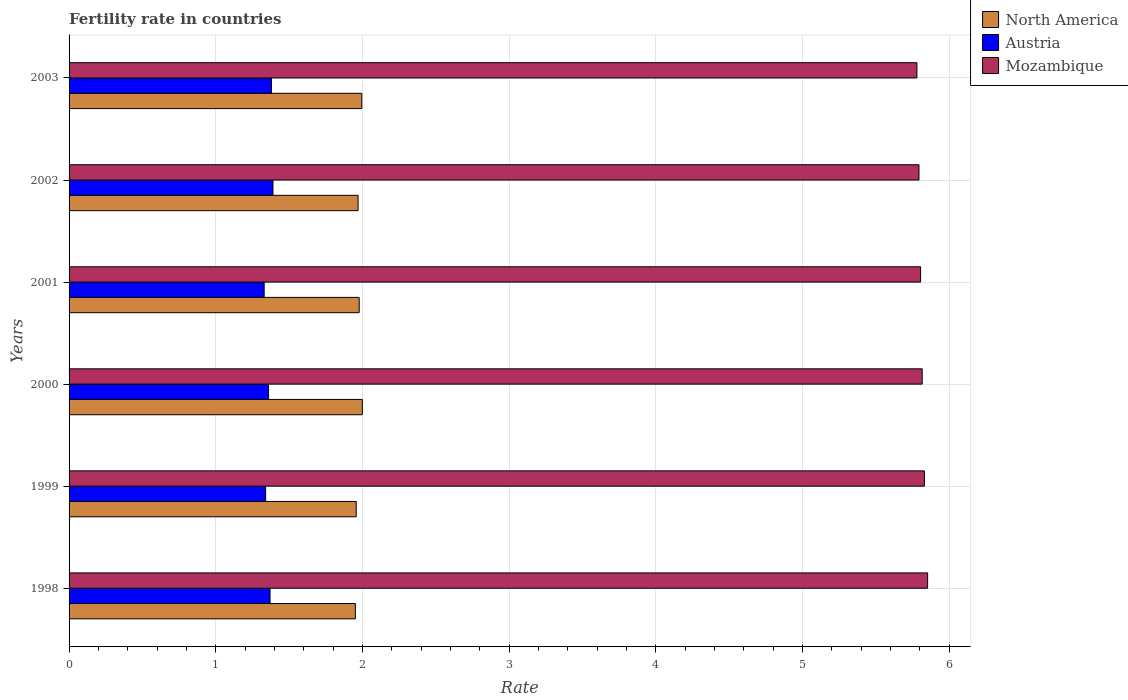How many groups of bars are there?
Offer a very short reply. 6. Are the number of bars per tick equal to the number of legend labels?
Provide a succinct answer. Yes. Are the number of bars on each tick of the Y-axis equal?
Provide a short and direct response. Yes. How many bars are there on the 6th tick from the bottom?
Provide a short and direct response. 3. What is the fertility rate in North America in 2000?
Provide a short and direct response. 2. Across all years, what is the maximum fertility rate in Mozambique?
Your answer should be very brief. 5.85. Across all years, what is the minimum fertility rate in Mozambique?
Give a very brief answer. 5.78. In which year was the fertility rate in North America minimum?
Offer a terse response. 1998. What is the total fertility rate in Mozambique in the graph?
Keep it short and to the point. 34.88. What is the difference between the fertility rate in North America in 1999 and that in 2002?
Keep it short and to the point. -0.01. What is the difference between the fertility rate in Austria in 2000 and the fertility rate in North America in 1998?
Your answer should be compact. -0.59. What is the average fertility rate in North America per year?
Offer a very short reply. 1.98. In the year 2002, what is the difference between the fertility rate in Austria and fertility rate in North America?
Ensure brevity in your answer.  -0.58. In how many years, is the fertility rate in Mozambique greater than 0.4 ?
Ensure brevity in your answer.  6. What is the ratio of the fertility rate in Mozambique in 2002 to that in 2003?
Make the answer very short. 1. Is the fertility rate in Mozambique in 1999 less than that in 2000?
Your answer should be compact. No. Is the difference between the fertility rate in Austria in 1998 and 2001 greater than the difference between the fertility rate in North America in 1998 and 2001?
Your response must be concise. Yes. What is the difference between the highest and the second highest fertility rate in Mozambique?
Keep it short and to the point. 0.02. What is the difference between the highest and the lowest fertility rate in Austria?
Your answer should be very brief. 0.06. How many years are there in the graph?
Provide a short and direct response. 6. Are the values on the major ticks of X-axis written in scientific E-notation?
Give a very brief answer. No. Does the graph contain grids?
Make the answer very short. Yes. Where does the legend appear in the graph?
Provide a succinct answer. Top right. How many legend labels are there?
Offer a very short reply. 3. What is the title of the graph?
Make the answer very short. Fertility rate in countries. What is the label or title of the X-axis?
Ensure brevity in your answer.  Rate. What is the Rate in North America in 1998?
Offer a terse response. 1.95. What is the Rate in Austria in 1998?
Give a very brief answer. 1.37. What is the Rate in Mozambique in 1998?
Your answer should be very brief. 5.85. What is the Rate in North America in 1999?
Offer a terse response. 1.96. What is the Rate in Austria in 1999?
Provide a succinct answer. 1.34. What is the Rate in Mozambique in 1999?
Make the answer very short. 5.83. What is the Rate in North America in 2000?
Provide a short and direct response. 2. What is the Rate in Austria in 2000?
Ensure brevity in your answer.  1.36. What is the Rate in Mozambique in 2000?
Your response must be concise. 5.82. What is the Rate of North America in 2001?
Offer a very short reply. 1.98. What is the Rate in Austria in 2001?
Provide a succinct answer. 1.33. What is the Rate in Mozambique in 2001?
Your response must be concise. 5.8. What is the Rate of North America in 2002?
Your answer should be compact. 1.97. What is the Rate in Austria in 2002?
Give a very brief answer. 1.39. What is the Rate of Mozambique in 2002?
Provide a succinct answer. 5.79. What is the Rate in North America in 2003?
Give a very brief answer. 2. What is the Rate of Austria in 2003?
Offer a terse response. 1.38. What is the Rate in Mozambique in 2003?
Make the answer very short. 5.78. Across all years, what is the maximum Rate in North America?
Your answer should be compact. 2. Across all years, what is the maximum Rate in Austria?
Provide a succinct answer. 1.39. Across all years, what is the maximum Rate in Mozambique?
Your answer should be compact. 5.85. Across all years, what is the minimum Rate of North America?
Your response must be concise. 1.95. Across all years, what is the minimum Rate in Austria?
Make the answer very short. 1.33. Across all years, what is the minimum Rate in Mozambique?
Give a very brief answer. 5.78. What is the total Rate in North America in the graph?
Ensure brevity in your answer.  11.85. What is the total Rate in Austria in the graph?
Your response must be concise. 8.17. What is the total Rate of Mozambique in the graph?
Keep it short and to the point. 34.88. What is the difference between the Rate of North America in 1998 and that in 1999?
Provide a short and direct response. -0.01. What is the difference between the Rate in Austria in 1998 and that in 1999?
Give a very brief answer. 0.03. What is the difference between the Rate in Mozambique in 1998 and that in 1999?
Ensure brevity in your answer.  0.02. What is the difference between the Rate of North America in 1998 and that in 2000?
Provide a short and direct response. -0.05. What is the difference between the Rate in Mozambique in 1998 and that in 2000?
Make the answer very short. 0.04. What is the difference between the Rate of North America in 1998 and that in 2001?
Your response must be concise. -0.03. What is the difference between the Rate of Mozambique in 1998 and that in 2001?
Give a very brief answer. 0.05. What is the difference between the Rate of North America in 1998 and that in 2002?
Offer a very short reply. -0.02. What is the difference between the Rate in Austria in 1998 and that in 2002?
Make the answer very short. -0.02. What is the difference between the Rate of Mozambique in 1998 and that in 2002?
Provide a succinct answer. 0.06. What is the difference between the Rate of North America in 1998 and that in 2003?
Offer a terse response. -0.04. What is the difference between the Rate in Austria in 1998 and that in 2003?
Offer a terse response. -0.01. What is the difference between the Rate of Mozambique in 1998 and that in 2003?
Ensure brevity in your answer.  0.07. What is the difference between the Rate of North America in 1999 and that in 2000?
Provide a succinct answer. -0.04. What is the difference between the Rate of Austria in 1999 and that in 2000?
Ensure brevity in your answer.  -0.02. What is the difference between the Rate in Mozambique in 1999 and that in 2000?
Provide a short and direct response. 0.01. What is the difference between the Rate in North America in 1999 and that in 2001?
Provide a short and direct response. -0.02. What is the difference between the Rate of Mozambique in 1999 and that in 2001?
Your answer should be compact. 0.03. What is the difference between the Rate in North America in 1999 and that in 2002?
Your answer should be compact. -0.01. What is the difference between the Rate of Mozambique in 1999 and that in 2002?
Your response must be concise. 0.04. What is the difference between the Rate of North America in 1999 and that in 2003?
Make the answer very short. -0.04. What is the difference between the Rate in Austria in 1999 and that in 2003?
Keep it short and to the point. -0.04. What is the difference between the Rate of Mozambique in 1999 and that in 2003?
Offer a terse response. 0.05. What is the difference between the Rate of North America in 2000 and that in 2001?
Give a very brief answer. 0.02. What is the difference between the Rate of Austria in 2000 and that in 2001?
Make the answer very short. 0.03. What is the difference between the Rate of Mozambique in 2000 and that in 2001?
Provide a succinct answer. 0.01. What is the difference between the Rate of North America in 2000 and that in 2002?
Your answer should be compact. 0.03. What is the difference between the Rate in Austria in 2000 and that in 2002?
Your answer should be very brief. -0.03. What is the difference between the Rate of Mozambique in 2000 and that in 2002?
Your response must be concise. 0.02. What is the difference between the Rate of North America in 2000 and that in 2003?
Make the answer very short. 0. What is the difference between the Rate of Austria in 2000 and that in 2003?
Make the answer very short. -0.02. What is the difference between the Rate of Mozambique in 2000 and that in 2003?
Your answer should be compact. 0.04. What is the difference between the Rate in North America in 2001 and that in 2002?
Ensure brevity in your answer.  0.01. What is the difference between the Rate in Austria in 2001 and that in 2002?
Your answer should be very brief. -0.06. What is the difference between the Rate in Mozambique in 2001 and that in 2002?
Your response must be concise. 0.01. What is the difference between the Rate in North America in 2001 and that in 2003?
Provide a succinct answer. -0.02. What is the difference between the Rate in Austria in 2001 and that in 2003?
Your answer should be very brief. -0.05. What is the difference between the Rate of Mozambique in 2001 and that in 2003?
Offer a terse response. 0.03. What is the difference between the Rate in North America in 2002 and that in 2003?
Make the answer very short. -0.03. What is the difference between the Rate of Mozambique in 2002 and that in 2003?
Your answer should be very brief. 0.01. What is the difference between the Rate of North America in 1998 and the Rate of Austria in 1999?
Give a very brief answer. 0.61. What is the difference between the Rate in North America in 1998 and the Rate in Mozambique in 1999?
Ensure brevity in your answer.  -3.88. What is the difference between the Rate of Austria in 1998 and the Rate of Mozambique in 1999?
Your response must be concise. -4.46. What is the difference between the Rate in North America in 1998 and the Rate in Austria in 2000?
Your response must be concise. 0.59. What is the difference between the Rate of North America in 1998 and the Rate of Mozambique in 2000?
Give a very brief answer. -3.86. What is the difference between the Rate of Austria in 1998 and the Rate of Mozambique in 2000?
Your answer should be very brief. -4.45. What is the difference between the Rate in North America in 1998 and the Rate in Austria in 2001?
Ensure brevity in your answer.  0.62. What is the difference between the Rate of North America in 1998 and the Rate of Mozambique in 2001?
Keep it short and to the point. -3.85. What is the difference between the Rate of Austria in 1998 and the Rate of Mozambique in 2001?
Give a very brief answer. -4.43. What is the difference between the Rate of North America in 1998 and the Rate of Austria in 2002?
Your answer should be very brief. 0.56. What is the difference between the Rate of North America in 1998 and the Rate of Mozambique in 2002?
Provide a short and direct response. -3.84. What is the difference between the Rate of Austria in 1998 and the Rate of Mozambique in 2002?
Give a very brief answer. -4.42. What is the difference between the Rate in North America in 1998 and the Rate in Austria in 2003?
Your response must be concise. 0.57. What is the difference between the Rate in North America in 1998 and the Rate in Mozambique in 2003?
Your answer should be very brief. -3.83. What is the difference between the Rate of Austria in 1998 and the Rate of Mozambique in 2003?
Your response must be concise. -4.41. What is the difference between the Rate of North America in 1999 and the Rate of Austria in 2000?
Keep it short and to the point. 0.6. What is the difference between the Rate in North America in 1999 and the Rate in Mozambique in 2000?
Keep it short and to the point. -3.86. What is the difference between the Rate in Austria in 1999 and the Rate in Mozambique in 2000?
Provide a short and direct response. -4.48. What is the difference between the Rate of North America in 1999 and the Rate of Austria in 2001?
Offer a very short reply. 0.63. What is the difference between the Rate in North America in 1999 and the Rate in Mozambique in 2001?
Offer a very short reply. -3.85. What is the difference between the Rate in Austria in 1999 and the Rate in Mozambique in 2001?
Your answer should be compact. -4.46. What is the difference between the Rate in North America in 1999 and the Rate in Austria in 2002?
Your answer should be compact. 0.57. What is the difference between the Rate of North America in 1999 and the Rate of Mozambique in 2002?
Provide a succinct answer. -3.84. What is the difference between the Rate of Austria in 1999 and the Rate of Mozambique in 2002?
Give a very brief answer. -4.45. What is the difference between the Rate of North America in 1999 and the Rate of Austria in 2003?
Make the answer very short. 0.58. What is the difference between the Rate in North America in 1999 and the Rate in Mozambique in 2003?
Offer a very short reply. -3.82. What is the difference between the Rate in Austria in 1999 and the Rate in Mozambique in 2003?
Make the answer very short. -4.44. What is the difference between the Rate in North America in 2000 and the Rate in Austria in 2001?
Your response must be concise. 0.67. What is the difference between the Rate in North America in 2000 and the Rate in Mozambique in 2001?
Give a very brief answer. -3.81. What is the difference between the Rate in Austria in 2000 and the Rate in Mozambique in 2001?
Your answer should be very brief. -4.45. What is the difference between the Rate of North America in 2000 and the Rate of Austria in 2002?
Offer a very short reply. 0.61. What is the difference between the Rate of North America in 2000 and the Rate of Mozambique in 2002?
Offer a terse response. -3.79. What is the difference between the Rate in Austria in 2000 and the Rate in Mozambique in 2002?
Your answer should be compact. -4.43. What is the difference between the Rate in North America in 2000 and the Rate in Austria in 2003?
Ensure brevity in your answer.  0.62. What is the difference between the Rate in North America in 2000 and the Rate in Mozambique in 2003?
Your answer should be very brief. -3.78. What is the difference between the Rate in Austria in 2000 and the Rate in Mozambique in 2003?
Ensure brevity in your answer.  -4.42. What is the difference between the Rate in North America in 2001 and the Rate in Austria in 2002?
Your response must be concise. 0.59. What is the difference between the Rate in North America in 2001 and the Rate in Mozambique in 2002?
Give a very brief answer. -3.82. What is the difference between the Rate in Austria in 2001 and the Rate in Mozambique in 2002?
Provide a short and direct response. -4.46. What is the difference between the Rate of North America in 2001 and the Rate of Austria in 2003?
Make the answer very short. 0.6. What is the difference between the Rate in North America in 2001 and the Rate in Mozambique in 2003?
Give a very brief answer. -3.8. What is the difference between the Rate in Austria in 2001 and the Rate in Mozambique in 2003?
Provide a succinct answer. -4.45. What is the difference between the Rate in North America in 2002 and the Rate in Austria in 2003?
Provide a succinct answer. 0.59. What is the difference between the Rate of North America in 2002 and the Rate of Mozambique in 2003?
Give a very brief answer. -3.81. What is the difference between the Rate in Austria in 2002 and the Rate in Mozambique in 2003?
Your answer should be compact. -4.39. What is the average Rate of North America per year?
Your answer should be very brief. 1.98. What is the average Rate in Austria per year?
Provide a short and direct response. 1.36. What is the average Rate of Mozambique per year?
Offer a terse response. 5.81. In the year 1998, what is the difference between the Rate in North America and Rate in Austria?
Provide a short and direct response. 0.58. In the year 1998, what is the difference between the Rate in North America and Rate in Mozambique?
Offer a very short reply. -3.9. In the year 1998, what is the difference between the Rate of Austria and Rate of Mozambique?
Your response must be concise. -4.48. In the year 1999, what is the difference between the Rate of North America and Rate of Austria?
Offer a very short reply. 0.62. In the year 1999, what is the difference between the Rate in North America and Rate in Mozambique?
Ensure brevity in your answer.  -3.87. In the year 1999, what is the difference between the Rate of Austria and Rate of Mozambique?
Your answer should be very brief. -4.49. In the year 2000, what is the difference between the Rate of North America and Rate of Austria?
Keep it short and to the point. 0.64. In the year 2000, what is the difference between the Rate in North America and Rate in Mozambique?
Your response must be concise. -3.82. In the year 2000, what is the difference between the Rate in Austria and Rate in Mozambique?
Offer a terse response. -4.46. In the year 2001, what is the difference between the Rate in North America and Rate in Austria?
Offer a terse response. 0.65. In the year 2001, what is the difference between the Rate in North America and Rate in Mozambique?
Offer a very short reply. -3.83. In the year 2001, what is the difference between the Rate in Austria and Rate in Mozambique?
Your answer should be compact. -4.47. In the year 2002, what is the difference between the Rate of North America and Rate of Austria?
Keep it short and to the point. 0.58. In the year 2002, what is the difference between the Rate of North America and Rate of Mozambique?
Offer a very short reply. -3.82. In the year 2002, what is the difference between the Rate in Austria and Rate in Mozambique?
Offer a very short reply. -4.4. In the year 2003, what is the difference between the Rate of North America and Rate of Austria?
Offer a terse response. 0.62. In the year 2003, what is the difference between the Rate of North America and Rate of Mozambique?
Your response must be concise. -3.78. In the year 2003, what is the difference between the Rate of Austria and Rate of Mozambique?
Provide a short and direct response. -4.4. What is the ratio of the Rate in North America in 1998 to that in 1999?
Your answer should be compact. 1. What is the ratio of the Rate in Austria in 1998 to that in 1999?
Keep it short and to the point. 1.02. What is the ratio of the Rate in North America in 1998 to that in 2000?
Your answer should be very brief. 0.98. What is the ratio of the Rate of Austria in 1998 to that in 2000?
Your response must be concise. 1.01. What is the ratio of the Rate of Mozambique in 1998 to that in 2000?
Offer a terse response. 1.01. What is the ratio of the Rate in Austria in 1998 to that in 2001?
Your answer should be compact. 1.03. What is the ratio of the Rate of Mozambique in 1998 to that in 2001?
Give a very brief answer. 1.01. What is the ratio of the Rate in Austria in 1998 to that in 2002?
Ensure brevity in your answer.  0.99. What is the ratio of the Rate in Mozambique in 1998 to that in 2002?
Provide a succinct answer. 1.01. What is the ratio of the Rate in North America in 1998 to that in 2003?
Your response must be concise. 0.98. What is the ratio of the Rate in Austria in 1998 to that in 2003?
Give a very brief answer. 0.99. What is the ratio of the Rate in Mozambique in 1998 to that in 2003?
Your response must be concise. 1.01. What is the ratio of the Rate in North America in 1999 to that in 2000?
Keep it short and to the point. 0.98. What is the ratio of the Rate in Austria in 1999 to that in 2000?
Ensure brevity in your answer.  0.99. What is the ratio of the Rate of Mozambique in 1999 to that in 2000?
Provide a short and direct response. 1. What is the ratio of the Rate of North America in 1999 to that in 2001?
Make the answer very short. 0.99. What is the ratio of the Rate in Austria in 1999 to that in 2001?
Offer a very short reply. 1.01. What is the ratio of the Rate in Austria in 1999 to that in 2002?
Your answer should be very brief. 0.96. What is the ratio of the Rate of Mozambique in 1999 to that in 2002?
Your answer should be compact. 1.01. What is the ratio of the Rate in North America in 1999 to that in 2003?
Make the answer very short. 0.98. What is the ratio of the Rate of Austria in 1999 to that in 2003?
Provide a succinct answer. 0.97. What is the ratio of the Rate of Mozambique in 1999 to that in 2003?
Provide a short and direct response. 1.01. What is the ratio of the Rate of North America in 2000 to that in 2001?
Give a very brief answer. 1.01. What is the ratio of the Rate of Austria in 2000 to that in 2001?
Offer a terse response. 1.02. What is the ratio of the Rate of Mozambique in 2000 to that in 2001?
Ensure brevity in your answer.  1. What is the ratio of the Rate in North America in 2000 to that in 2002?
Ensure brevity in your answer.  1.01. What is the ratio of the Rate in Austria in 2000 to that in 2002?
Offer a very short reply. 0.98. What is the ratio of the Rate of Mozambique in 2000 to that in 2002?
Offer a terse response. 1. What is the ratio of the Rate of Austria in 2000 to that in 2003?
Make the answer very short. 0.99. What is the ratio of the Rate in North America in 2001 to that in 2002?
Your answer should be very brief. 1. What is the ratio of the Rate in Austria in 2001 to that in 2002?
Ensure brevity in your answer.  0.96. What is the ratio of the Rate in Mozambique in 2001 to that in 2002?
Keep it short and to the point. 1. What is the ratio of the Rate in North America in 2001 to that in 2003?
Make the answer very short. 0.99. What is the ratio of the Rate in Austria in 2001 to that in 2003?
Offer a very short reply. 0.96. What is the ratio of the Rate in Mozambique in 2001 to that in 2003?
Give a very brief answer. 1. What is the ratio of the Rate of North America in 2002 to that in 2003?
Your answer should be very brief. 0.99. What is the ratio of the Rate in Austria in 2002 to that in 2003?
Ensure brevity in your answer.  1.01. What is the difference between the highest and the second highest Rate in North America?
Provide a short and direct response. 0. What is the difference between the highest and the second highest Rate in Austria?
Keep it short and to the point. 0.01. What is the difference between the highest and the second highest Rate of Mozambique?
Provide a succinct answer. 0.02. What is the difference between the highest and the lowest Rate in North America?
Make the answer very short. 0.05. What is the difference between the highest and the lowest Rate of Austria?
Make the answer very short. 0.06. What is the difference between the highest and the lowest Rate in Mozambique?
Your answer should be compact. 0.07. 